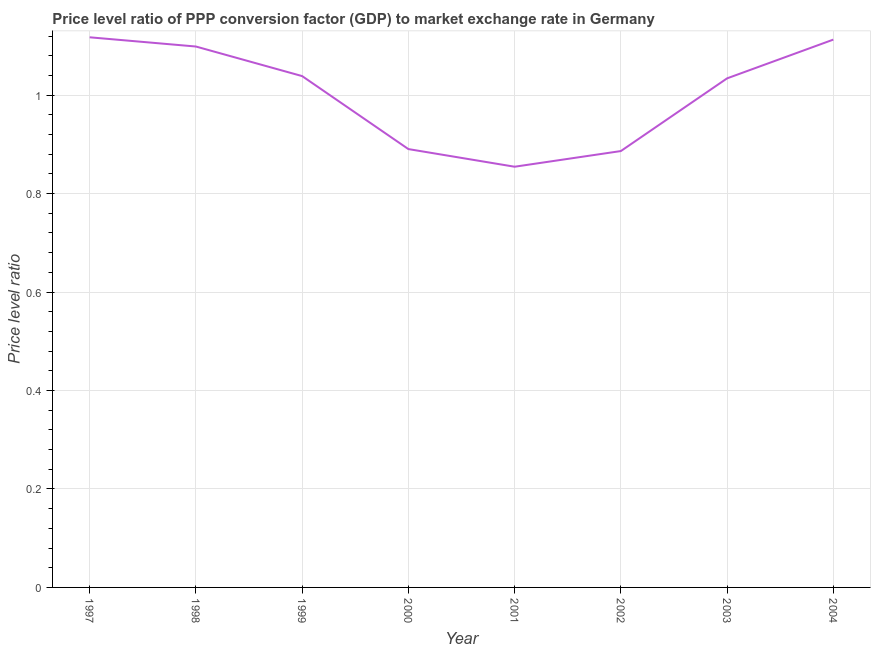What is the price level ratio in 2003?
Provide a short and direct response. 1.03. Across all years, what is the maximum price level ratio?
Ensure brevity in your answer.  1.12. Across all years, what is the minimum price level ratio?
Make the answer very short. 0.85. In which year was the price level ratio maximum?
Ensure brevity in your answer.  1997. What is the sum of the price level ratio?
Your response must be concise. 8.03. What is the difference between the price level ratio in 1997 and 2003?
Offer a very short reply. 0.08. What is the average price level ratio per year?
Keep it short and to the point. 1. What is the median price level ratio?
Your answer should be very brief. 1.04. Do a majority of the years between 1999 and 1997 (inclusive) have price level ratio greater than 0.32 ?
Your answer should be compact. No. What is the ratio of the price level ratio in 1998 to that in 2000?
Provide a succinct answer. 1.23. Is the price level ratio in 2001 less than that in 2003?
Keep it short and to the point. Yes. What is the difference between the highest and the second highest price level ratio?
Ensure brevity in your answer.  0. What is the difference between the highest and the lowest price level ratio?
Your answer should be compact. 0.26. Does the price level ratio monotonically increase over the years?
Give a very brief answer. No. How many years are there in the graph?
Your answer should be compact. 8. What is the difference between two consecutive major ticks on the Y-axis?
Your answer should be very brief. 0.2. What is the title of the graph?
Provide a succinct answer. Price level ratio of PPP conversion factor (GDP) to market exchange rate in Germany. What is the label or title of the Y-axis?
Offer a very short reply. Price level ratio. What is the Price level ratio of 1997?
Offer a very short reply. 1.12. What is the Price level ratio in 1998?
Make the answer very short. 1.1. What is the Price level ratio of 1999?
Your answer should be compact. 1.04. What is the Price level ratio of 2000?
Your answer should be very brief. 0.89. What is the Price level ratio in 2001?
Your answer should be very brief. 0.85. What is the Price level ratio of 2002?
Offer a terse response. 0.89. What is the Price level ratio in 2003?
Your response must be concise. 1.03. What is the Price level ratio in 2004?
Provide a succinct answer. 1.11. What is the difference between the Price level ratio in 1997 and 1998?
Provide a succinct answer. 0.02. What is the difference between the Price level ratio in 1997 and 1999?
Ensure brevity in your answer.  0.08. What is the difference between the Price level ratio in 1997 and 2000?
Keep it short and to the point. 0.23. What is the difference between the Price level ratio in 1997 and 2001?
Give a very brief answer. 0.26. What is the difference between the Price level ratio in 1997 and 2002?
Offer a terse response. 0.23. What is the difference between the Price level ratio in 1997 and 2003?
Keep it short and to the point. 0.08. What is the difference between the Price level ratio in 1997 and 2004?
Offer a very short reply. 0. What is the difference between the Price level ratio in 1998 and 1999?
Your answer should be very brief. 0.06. What is the difference between the Price level ratio in 1998 and 2000?
Keep it short and to the point. 0.21. What is the difference between the Price level ratio in 1998 and 2001?
Offer a very short reply. 0.24. What is the difference between the Price level ratio in 1998 and 2002?
Your answer should be very brief. 0.21. What is the difference between the Price level ratio in 1998 and 2003?
Your response must be concise. 0.06. What is the difference between the Price level ratio in 1998 and 2004?
Give a very brief answer. -0.01. What is the difference between the Price level ratio in 1999 and 2000?
Offer a terse response. 0.15. What is the difference between the Price level ratio in 1999 and 2001?
Provide a succinct answer. 0.18. What is the difference between the Price level ratio in 1999 and 2002?
Your answer should be compact. 0.15. What is the difference between the Price level ratio in 1999 and 2003?
Your response must be concise. 0. What is the difference between the Price level ratio in 1999 and 2004?
Make the answer very short. -0.07. What is the difference between the Price level ratio in 2000 and 2001?
Offer a terse response. 0.04. What is the difference between the Price level ratio in 2000 and 2002?
Give a very brief answer. 0. What is the difference between the Price level ratio in 2000 and 2003?
Provide a succinct answer. -0.14. What is the difference between the Price level ratio in 2000 and 2004?
Offer a very short reply. -0.22. What is the difference between the Price level ratio in 2001 and 2002?
Your response must be concise. -0.03. What is the difference between the Price level ratio in 2001 and 2003?
Provide a short and direct response. -0.18. What is the difference between the Price level ratio in 2001 and 2004?
Make the answer very short. -0.26. What is the difference between the Price level ratio in 2002 and 2003?
Ensure brevity in your answer.  -0.15. What is the difference between the Price level ratio in 2002 and 2004?
Give a very brief answer. -0.23. What is the difference between the Price level ratio in 2003 and 2004?
Your answer should be very brief. -0.08. What is the ratio of the Price level ratio in 1997 to that in 1999?
Your answer should be very brief. 1.08. What is the ratio of the Price level ratio in 1997 to that in 2000?
Ensure brevity in your answer.  1.25. What is the ratio of the Price level ratio in 1997 to that in 2001?
Provide a short and direct response. 1.31. What is the ratio of the Price level ratio in 1997 to that in 2002?
Make the answer very short. 1.26. What is the ratio of the Price level ratio in 1997 to that in 2003?
Ensure brevity in your answer.  1.08. What is the ratio of the Price level ratio in 1997 to that in 2004?
Your response must be concise. 1. What is the ratio of the Price level ratio in 1998 to that in 1999?
Provide a short and direct response. 1.06. What is the ratio of the Price level ratio in 1998 to that in 2000?
Make the answer very short. 1.23. What is the ratio of the Price level ratio in 1998 to that in 2001?
Give a very brief answer. 1.29. What is the ratio of the Price level ratio in 1998 to that in 2002?
Make the answer very short. 1.24. What is the ratio of the Price level ratio in 1998 to that in 2003?
Your answer should be compact. 1.06. What is the ratio of the Price level ratio in 1999 to that in 2000?
Give a very brief answer. 1.17. What is the ratio of the Price level ratio in 1999 to that in 2001?
Keep it short and to the point. 1.22. What is the ratio of the Price level ratio in 1999 to that in 2002?
Offer a very short reply. 1.17. What is the ratio of the Price level ratio in 1999 to that in 2003?
Your answer should be compact. 1. What is the ratio of the Price level ratio in 1999 to that in 2004?
Offer a terse response. 0.93. What is the ratio of the Price level ratio in 2000 to that in 2001?
Ensure brevity in your answer.  1.04. What is the ratio of the Price level ratio in 2000 to that in 2003?
Your answer should be very brief. 0.86. What is the ratio of the Price level ratio in 2000 to that in 2004?
Provide a short and direct response. 0.8. What is the ratio of the Price level ratio in 2001 to that in 2002?
Keep it short and to the point. 0.96. What is the ratio of the Price level ratio in 2001 to that in 2003?
Your response must be concise. 0.83. What is the ratio of the Price level ratio in 2001 to that in 2004?
Provide a succinct answer. 0.77. What is the ratio of the Price level ratio in 2002 to that in 2003?
Offer a very short reply. 0.86. What is the ratio of the Price level ratio in 2002 to that in 2004?
Offer a very short reply. 0.8. What is the ratio of the Price level ratio in 2003 to that in 2004?
Provide a succinct answer. 0.93. 